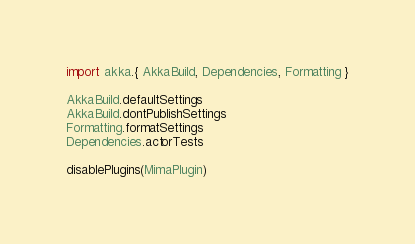<code> <loc_0><loc_0><loc_500><loc_500><_Scala_>import akka.{ AkkaBuild, Dependencies, Formatting }

AkkaBuild.defaultSettings
AkkaBuild.dontPublishSettings
Formatting.formatSettings
Dependencies.actorTests

disablePlugins(MimaPlugin)
</code> 